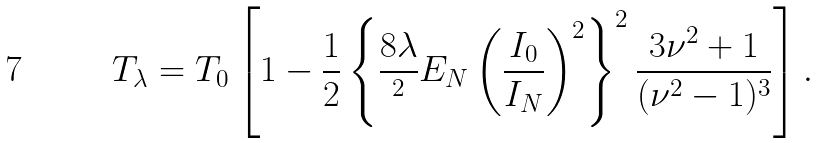<formula> <loc_0><loc_0><loc_500><loc_500>T _ { \lambda } = T _ { 0 } \left [ 1 - \frac { 1 } { 2 } \left \{ \frac { 8 \lambda } { { } ^ { 2 } } E _ { N } \left ( \frac { I _ { 0 } } { I _ { N } } \right ) ^ { 2 } \right \} ^ { 2 } \frac { 3 \nu ^ { 2 } + 1 } { ( \nu ^ { 2 } - 1 ) ^ { 3 } } \right ] .</formula> 